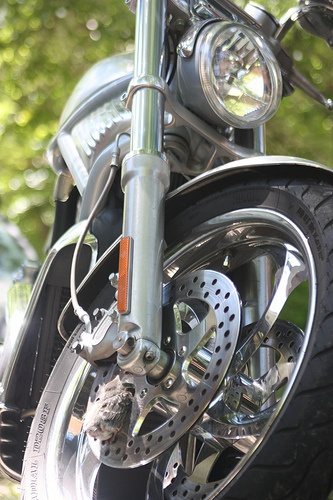Describe the objects in this image and their specific colors. I can see motorcycle in black, gray, olive, darkgray, and lightgray tones and bird in olive, lightgray, gray, darkgray, and black tones in this image. 